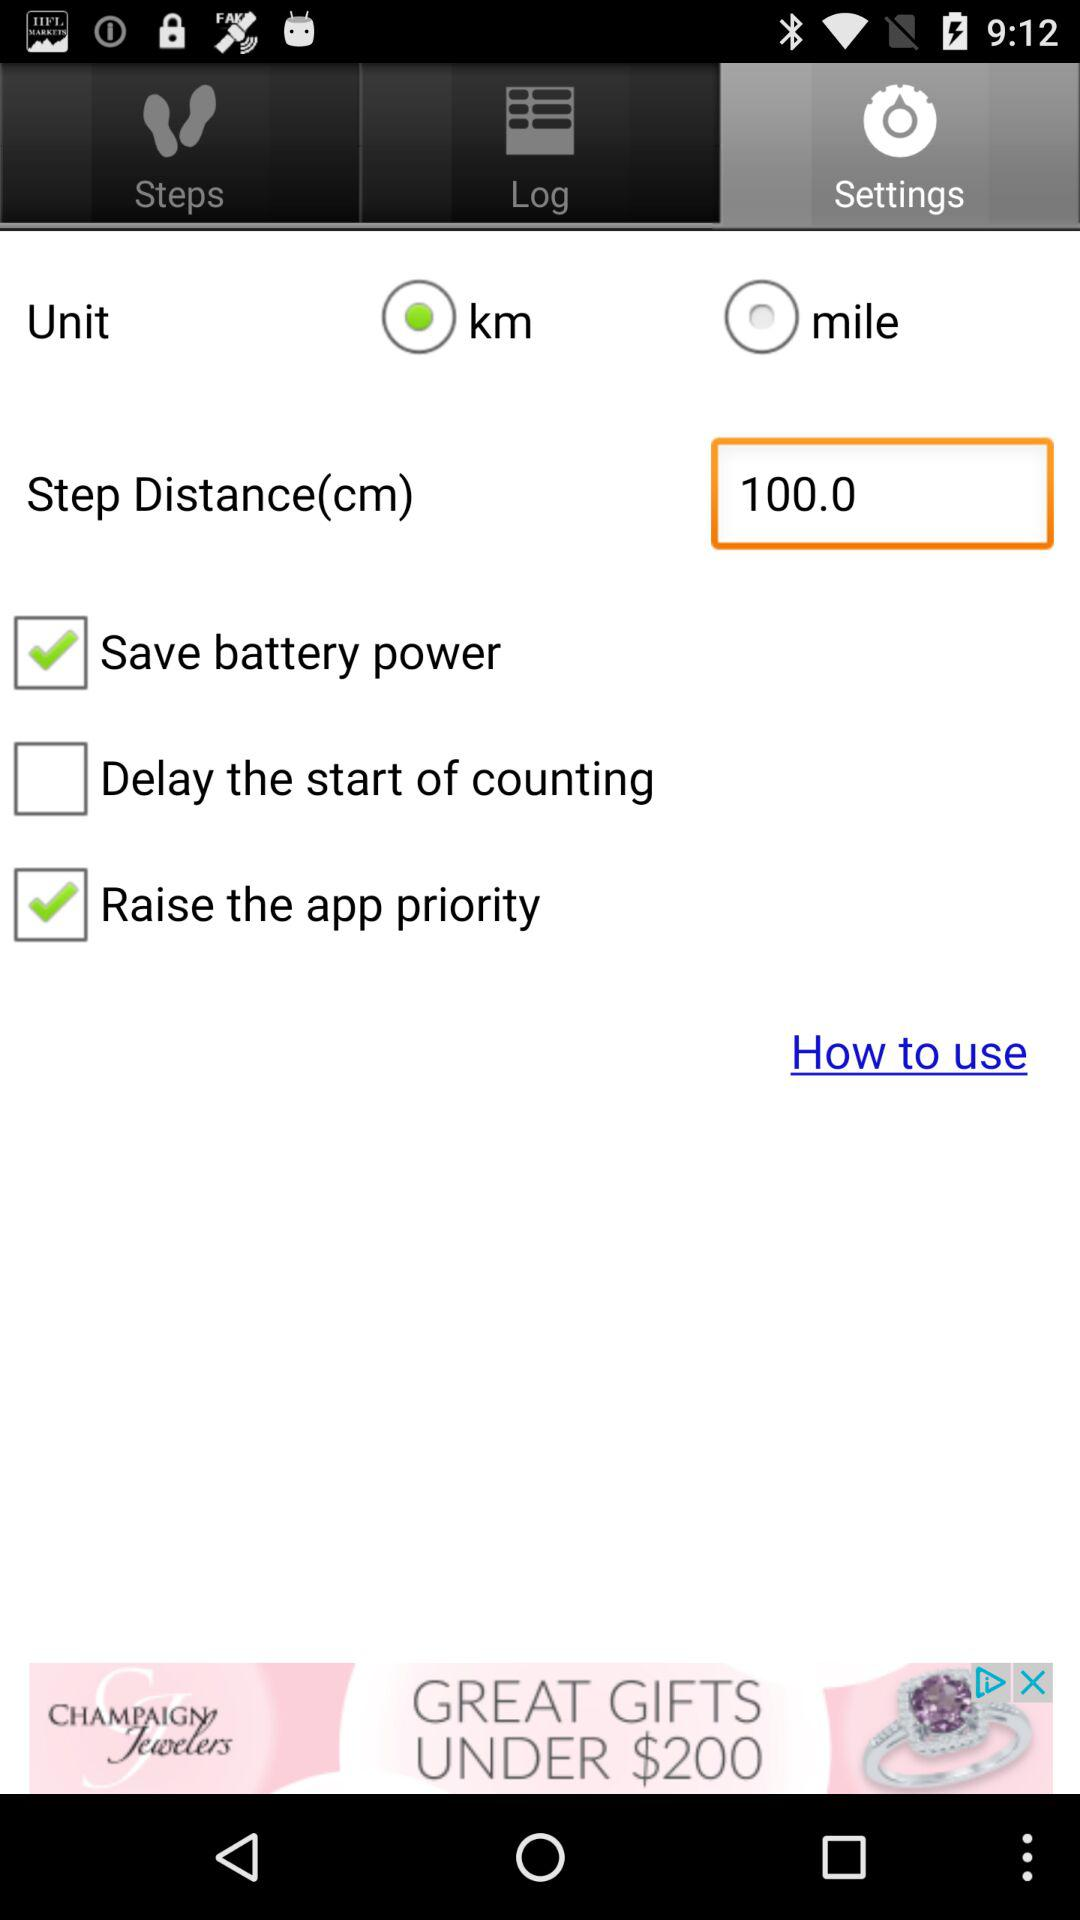What is the status of "Delay the start of counting"? The status is off. 